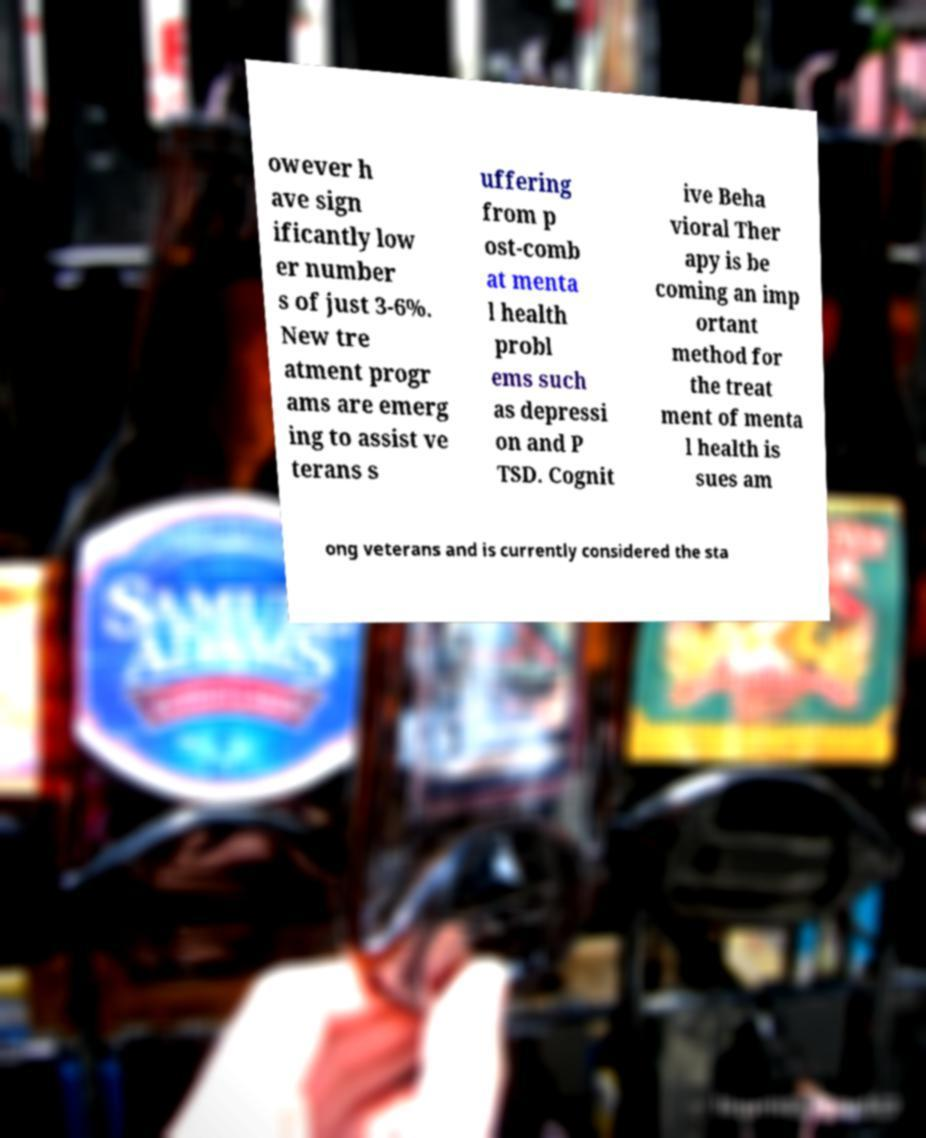I need the written content from this picture converted into text. Can you do that? owever h ave sign ificantly low er number s of just 3-6%. New tre atment progr ams are emerg ing to assist ve terans s uffering from p ost-comb at menta l health probl ems such as depressi on and P TSD. Cognit ive Beha vioral Ther apy is be coming an imp ortant method for the treat ment of menta l health is sues am ong veterans and is currently considered the sta 